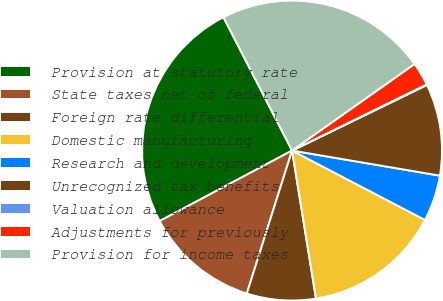Convert chart. <chart><loc_0><loc_0><loc_500><loc_500><pie_chart><fcel>Provision at statutory rate<fcel>State taxes net of federal<fcel>Foreign rate differential<fcel>Domestic manufacturing<fcel>Research and development<fcel>Unrecognized tax benefits<fcel>Valuation allowance<fcel>Adjustments for previously<fcel>Provision for income taxes<nl><fcel>25.22%<fcel>12.33%<fcel>7.43%<fcel>14.79%<fcel>4.98%<fcel>9.88%<fcel>0.07%<fcel>2.52%<fcel>22.77%<nl></chart> 